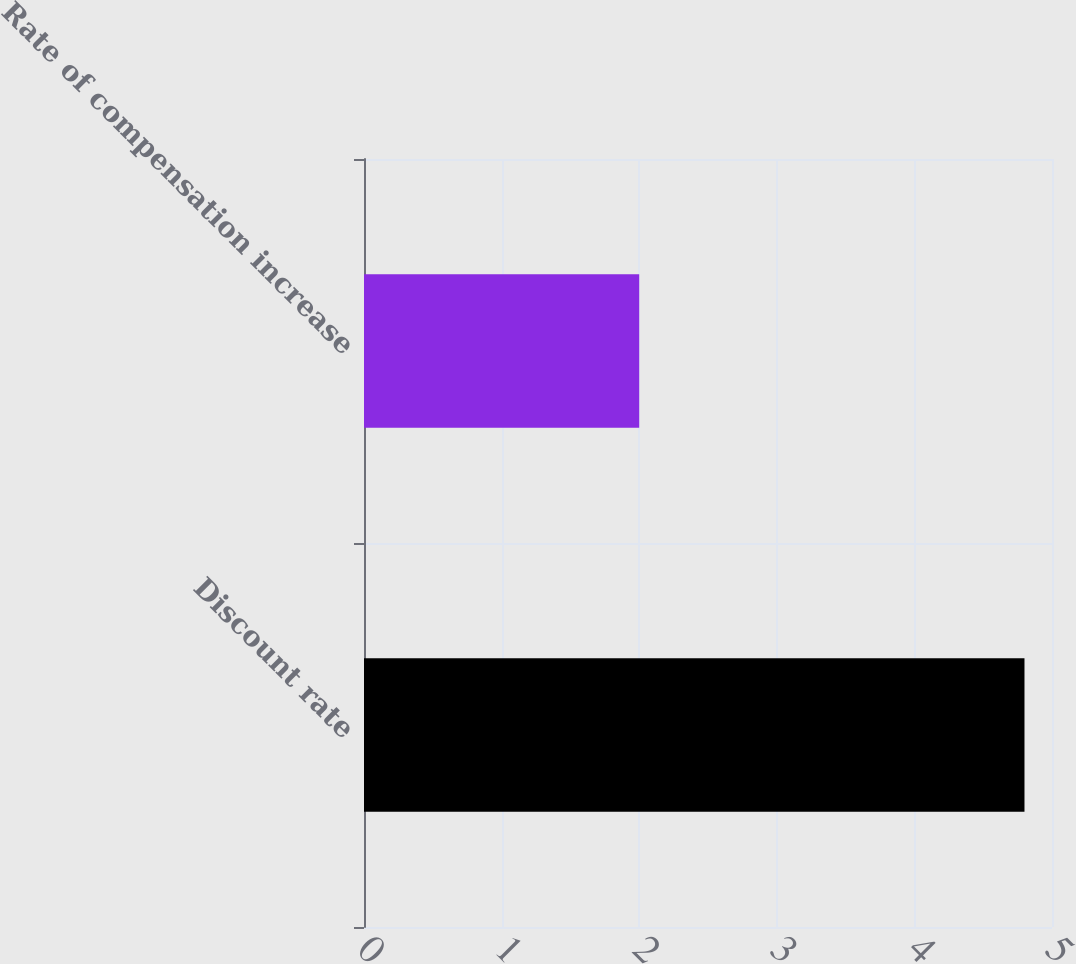Convert chart. <chart><loc_0><loc_0><loc_500><loc_500><bar_chart><fcel>Discount rate<fcel>Rate of compensation increase<nl><fcel>4.8<fcel>2<nl></chart> 